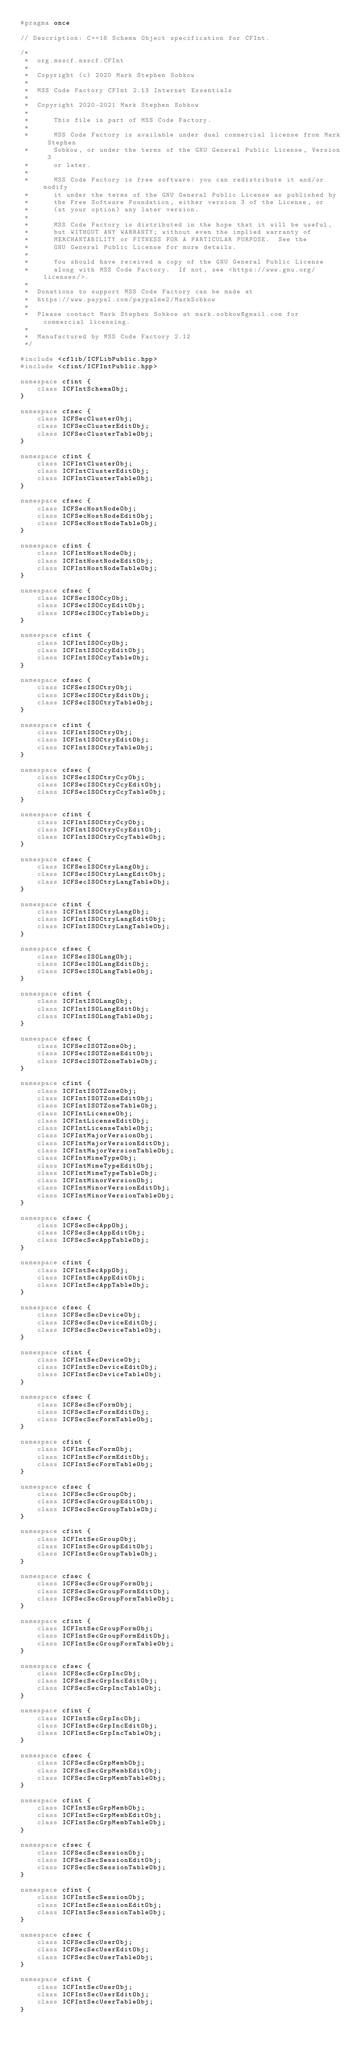Convert code to text. <code><loc_0><loc_0><loc_500><loc_500><_C++_>#pragma once

// Description: C++18 Schema Object specification for CFInt.

/*
 *	org.msscf.msscf.CFInt
 *
 *	Copyright (c) 2020 Mark Stephen Sobkow
 *	
 *	MSS Code Factory CFInt 2.13 Internet Essentials
 *	
 *	Copyright 2020-2021 Mark Stephen Sobkow
 *	
 *		This file is part of MSS Code Factory.
 *	
 *		MSS Code Factory is available under dual commercial license from Mark Stephen
 *		Sobkow, or under the terms of the GNU General Public License, Version 3
 *		or later.
 *	
 *	    MSS Code Factory is free software: you can redistribute it and/or modify
 *	    it under the terms of the GNU General Public License as published by
 *	    the Free Software Foundation, either version 3 of the License, or
 *	    (at your option) any later version.
 *	
 *	    MSS Code Factory is distributed in the hope that it will be useful,
 *	    but WITHOUT ANY WARRANTY; without even the implied warranty of
 *	    MERCHANTABILITY or FITNESS FOR A PARTICULAR PURPOSE.  See the
 *	    GNU General Public License for more details.
 *	
 *	    You should have received a copy of the GNU General Public License
 *	    along with MSS Code Factory.  If not, see <https://www.gnu.org/licenses/>.
 *	
 *	Donations to support MSS Code Factory can be made at
 *	https://www.paypal.com/paypalme2/MarkSobkow
 *	
 *	Please contact Mark Stephen Sobkow at mark.sobkow@gmail.com for commercial licensing.
 *
 *	Manufactured by MSS Code Factory 2.12
 */

#include <cflib/ICFLibPublic.hpp>
#include <cfint/ICFIntPublic.hpp>

namespace cfint {
	class ICFIntSchemaObj;
}

namespace cfsec {
	class ICFSecClusterObj;
	class ICFSecClusterEditObj;
	class ICFSecClusterTableObj;
}

namespace cfint { 
	class ICFIntClusterObj;
	class ICFIntClusterEditObj;
	class ICFIntClusterTableObj;
}

namespace cfsec {
	class ICFSecHostNodeObj;
	class ICFSecHostNodeEditObj;
	class ICFSecHostNodeTableObj;
}

namespace cfint { 
	class ICFIntHostNodeObj;
	class ICFIntHostNodeEditObj;
	class ICFIntHostNodeTableObj;
}

namespace cfsec {
	class ICFSecISOCcyObj;
	class ICFSecISOCcyEditObj;
	class ICFSecISOCcyTableObj;
}

namespace cfint { 
	class ICFIntISOCcyObj;
	class ICFIntISOCcyEditObj;
	class ICFIntISOCcyTableObj;
}

namespace cfsec {
	class ICFSecISOCtryObj;
	class ICFSecISOCtryEditObj;
	class ICFSecISOCtryTableObj;
}

namespace cfint { 
	class ICFIntISOCtryObj;
	class ICFIntISOCtryEditObj;
	class ICFIntISOCtryTableObj;
}

namespace cfsec {
	class ICFSecISOCtryCcyObj;
	class ICFSecISOCtryCcyEditObj;
	class ICFSecISOCtryCcyTableObj;
}

namespace cfint { 
	class ICFIntISOCtryCcyObj;
	class ICFIntISOCtryCcyEditObj;
	class ICFIntISOCtryCcyTableObj;
}

namespace cfsec {
	class ICFSecISOCtryLangObj;
	class ICFSecISOCtryLangEditObj;
	class ICFSecISOCtryLangTableObj;
}

namespace cfint { 
	class ICFIntISOCtryLangObj;
	class ICFIntISOCtryLangEditObj;
	class ICFIntISOCtryLangTableObj;
}

namespace cfsec {
	class ICFSecISOLangObj;
	class ICFSecISOLangEditObj;
	class ICFSecISOLangTableObj;
}

namespace cfint { 
	class ICFIntISOLangObj;
	class ICFIntISOLangEditObj;
	class ICFIntISOLangTableObj;
}

namespace cfsec {
	class ICFSecISOTZoneObj;
	class ICFSecISOTZoneEditObj;
	class ICFSecISOTZoneTableObj;
}

namespace cfint { 
	class ICFIntISOTZoneObj;
	class ICFIntISOTZoneEditObj;
	class ICFIntISOTZoneTableObj;
	class ICFIntLicenseObj;
	class ICFIntLicenseEditObj;
	class ICFIntLicenseTableObj;
	class ICFIntMajorVersionObj;
	class ICFIntMajorVersionEditObj;
	class ICFIntMajorVersionTableObj;
	class ICFIntMimeTypeObj;
	class ICFIntMimeTypeEditObj;
	class ICFIntMimeTypeTableObj;
	class ICFIntMinorVersionObj;
	class ICFIntMinorVersionEditObj;
	class ICFIntMinorVersionTableObj;
}

namespace cfsec {
	class ICFSecSecAppObj;
	class ICFSecSecAppEditObj;
	class ICFSecSecAppTableObj;
}

namespace cfint { 
	class ICFIntSecAppObj;
	class ICFIntSecAppEditObj;
	class ICFIntSecAppTableObj;
}

namespace cfsec {
	class ICFSecSecDeviceObj;
	class ICFSecSecDeviceEditObj;
	class ICFSecSecDeviceTableObj;
}

namespace cfint { 
	class ICFIntSecDeviceObj;
	class ICFIntSecDeviceEditObj;
	class ICFIntSecDeviceTableObj;
}

namespace cfsec {
	class ICFSecSecFormObj;
	class ICFSecSecFormEditObj;
	class ICFSecSecFormTableObj;
}

namespace cfint { 
	class ICFIntSecFormObj;
	class ICFIntSecFormEditObj;
	class ICFIntSecFormTableObj;
}

namespace cfsec {
	class ICFSecSecGroupObj;
	class ICFSecSecGroupEditObj;
	class ICFSecSecGroupTableObj;
}

namespace cfint { 
	class ICFIntSecGroupObj;
	class ICFIntSecGroupEditObj;
	class ICFIntSecGroupTableObj;
}

namespace cfsec {
	class ICFSecSecGroupFormObj;
	class ICFSecSecGroupFormEditObj;
	class ICFSecSecGroupFormTableObj;
}

namespace cfint { 
	class ICFIntSecGroupFormObj;
	class ICFIntSecGroupFormEditObj;
	class ICFIntSecGroupFormTableObj;
}

namespace cfsec {
	class ICFSecSecGrpIncObj;
	class ICFSecSecGrpIncEditObj;
	class ICFSecSecGrpIncTableObj;
}

namespace cfint { 
	class ICFIntSecGrpIncObj;
	class ICFIntSecGrpIncEditObj;
	class ICFIntSecGrpIncTableObj;
}

namespace cfsec {
	class ICFSecSecGrpMembObj;
	class ICFSecSecGrpMembEditObj;
	class ICFSecSecGrpMembTableObj;
}

namespace cfint { 
	class ICFIntSecGrpMembObj;
	class ICFIntSecGrpMembEditObj;
	class ICFIntSecGrpMembTableObj;
}

namespace cfsec {
	class ICFSecSecSessionObj;
	class ICFSecSecSessionEditObj;
	class ICFSecSecSessionTableObj;
}

namespace cfint { 
	class ICFIntSecSessionObj;
	class ICFIntSecSessionEditObj;
	class ICFIntSecSessionTableObj;
}

namespace cfsec {
	class ICFSecSecUserObj;
	class ICFSecSecUserEditObj;
	class ICFSecSecUserTableObj;
}

namespace cfint { 
	class ICFIntSecUserObj;
	class ICFIntSecUserEditObj;
	class ICFIntSecUserTableObj;
}
</code> 